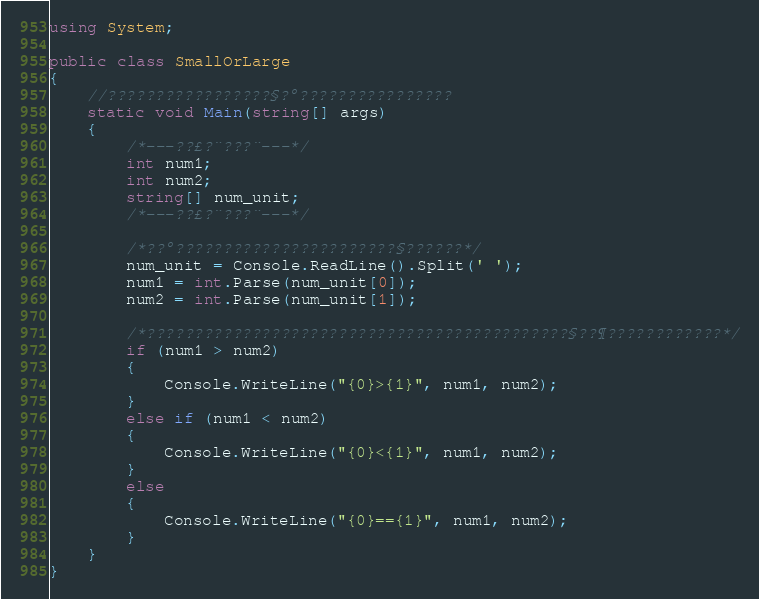Convert code to text. <code><loc_0><loc_0><loc_500><loc_500><_C#_>using System;

public class SmallOrLarge
{
    //?????????????????§?°????????????????
    static void Main(string[] args)
    {
        /*---??£?¨???¨---*/
        int num1;
        int num2;
        string[] num_unit;
        /*---??£?¨???¨---*/

        /*??°???????????????????????§??????*/
        num_unit = Console.ReadLine().Split(' ');
        num1 = int.Parse(num_unit[0]);
        num2 = int.Parse(num_unit[1]);

        /*????????????????????????????????????????????§??¶????????????*/
        if (num1 > num2)
        {
            Console.WriteLine("{0}>{1}", num1, num2);
        }
        else if (num1 < num2)
        {
            Console.WriteLine("{0}<{1}", num1, num2);
        }
        else
        {
            Console.WriteLine("{0}=={1}", num1, num2);
        }
    }
}</code> 